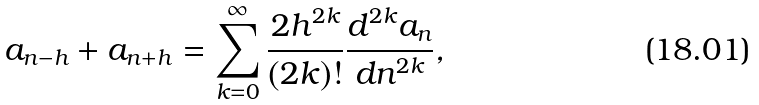Convert formula to latex. <formula><loc_0><loc_0><loc_500><loc_500>a _ { n - h } + a _ { n + h } = \sum _ { k = 0 } ^ { \infty } \frac { 2 h ^ { 2 k } } { ( 2 k ) ! } \frac { d ^ { 2 k } a _ { n } } { d n ^ { 2 k } } ,</formula> 